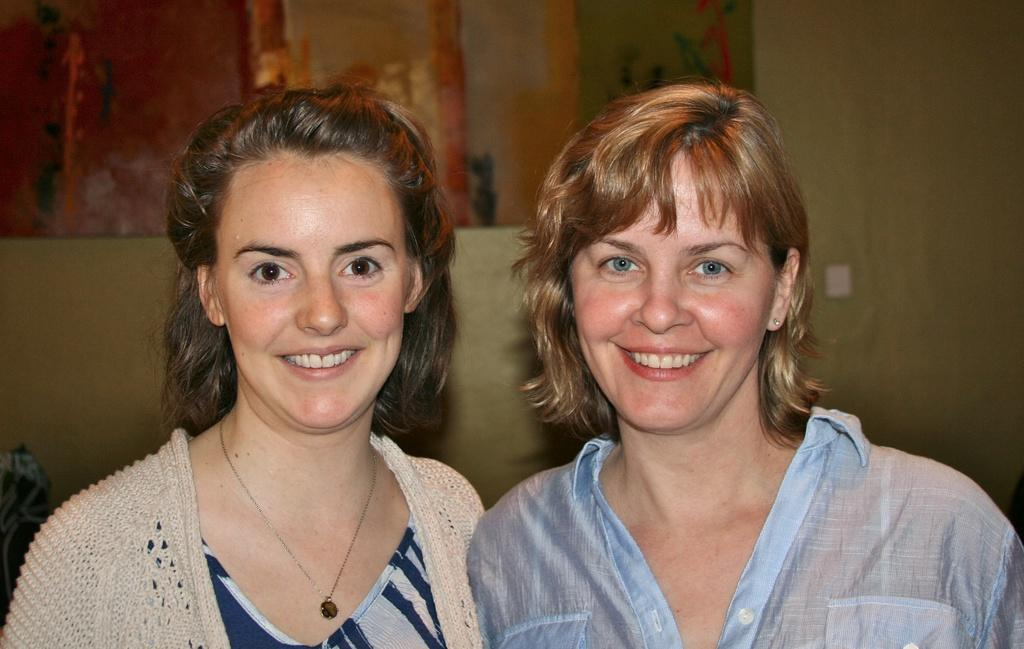How many people are in the foreground of the image? There are two women in the foreground of the image. What are the women doing in the image? The women are standing and smiling. What can be seen in the background of the image? There is a wall in the background of the image. What type of spoon is the scarecrow holding in the image? There is no scarecrow or spoon present in the image. 